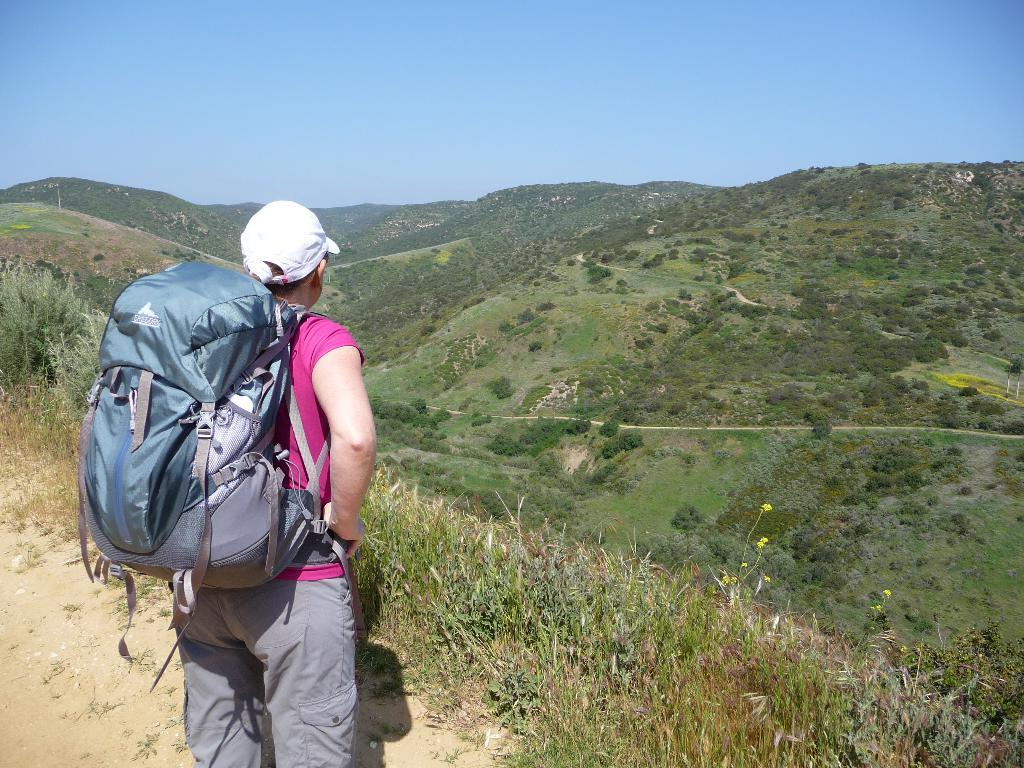What is the main subject of the image? There is a woman standing in the image. What is the woman standing on? The woman is standing on the ground. What object can be seen in the image besides the woman? There is a bag in the image. What type of natural landscape is visible in the image? Mountains and the sky are visible in the image. What is the degree of zinc in the image? There is no mention of zinc or any chemical element in the image, so it is not possible to determine its degree. 